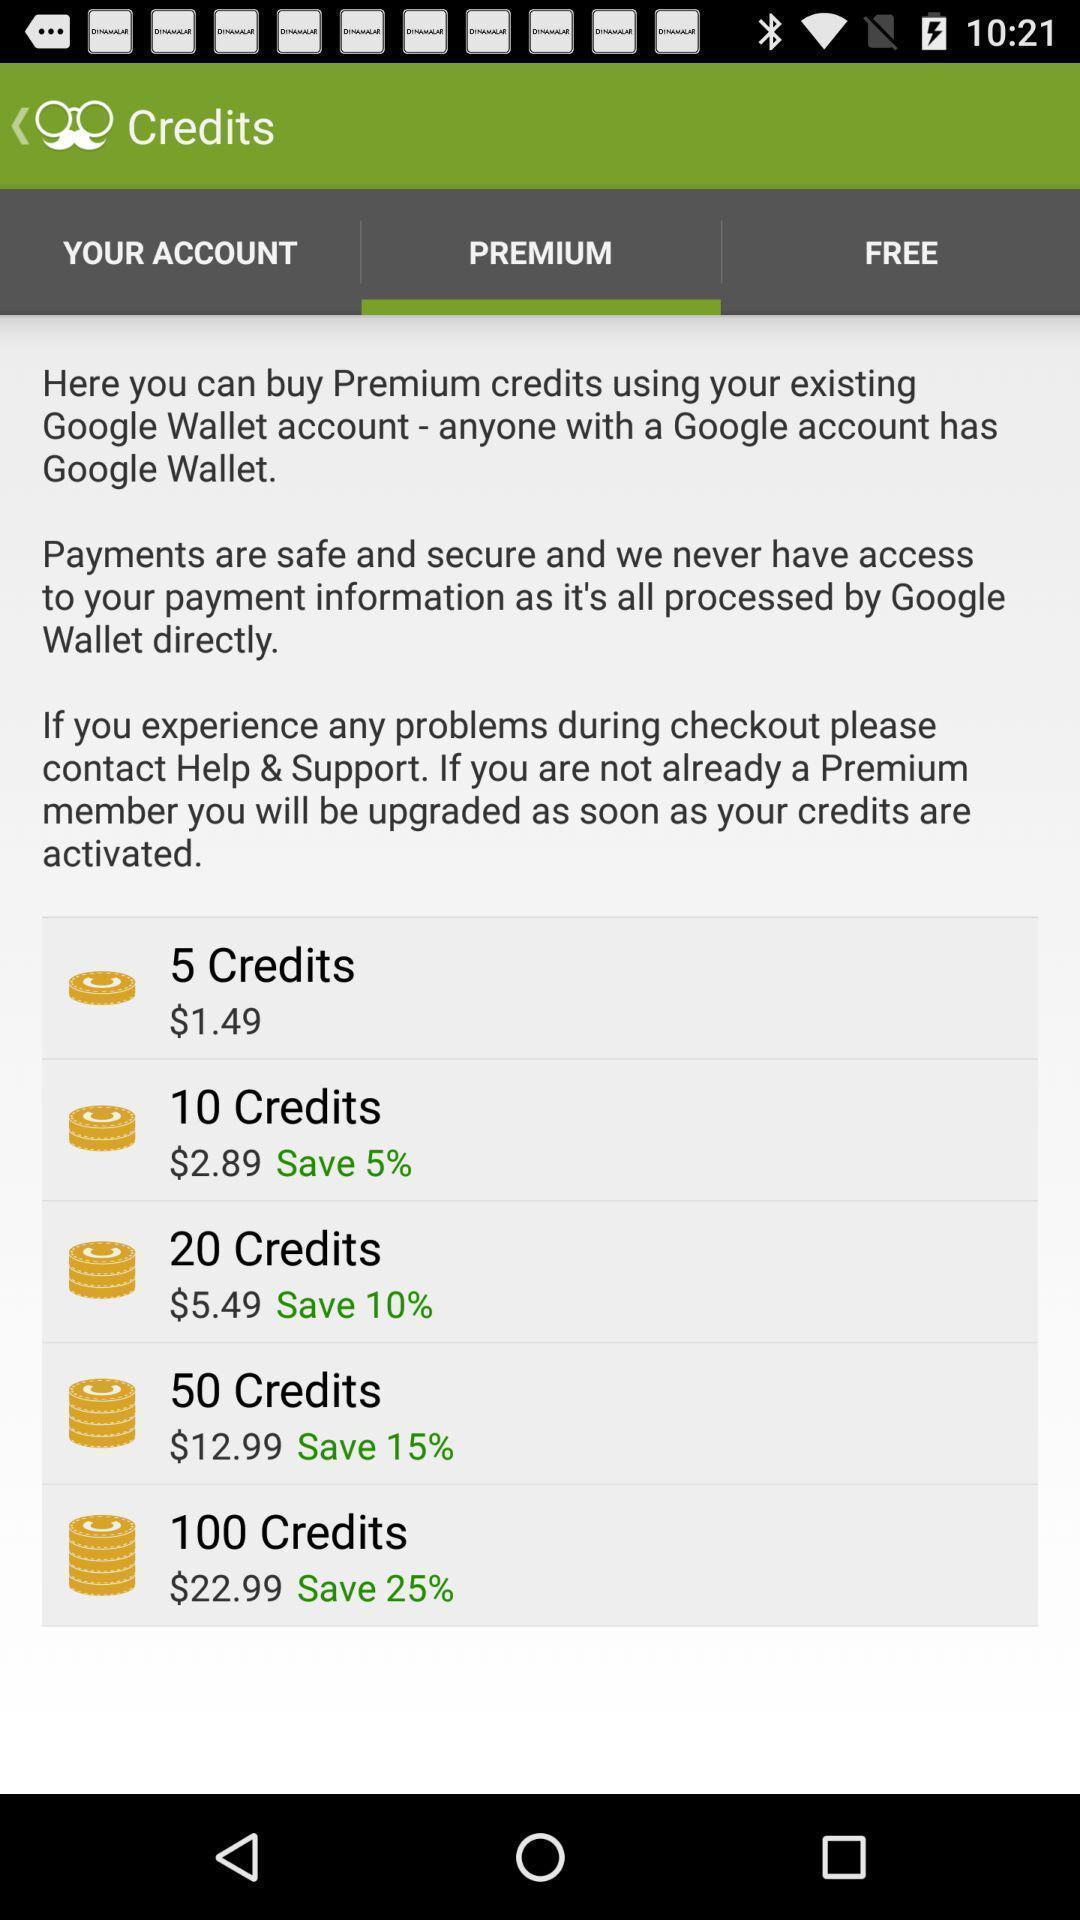What is the overall content of this screenshot? Screen shows about a premium account. 